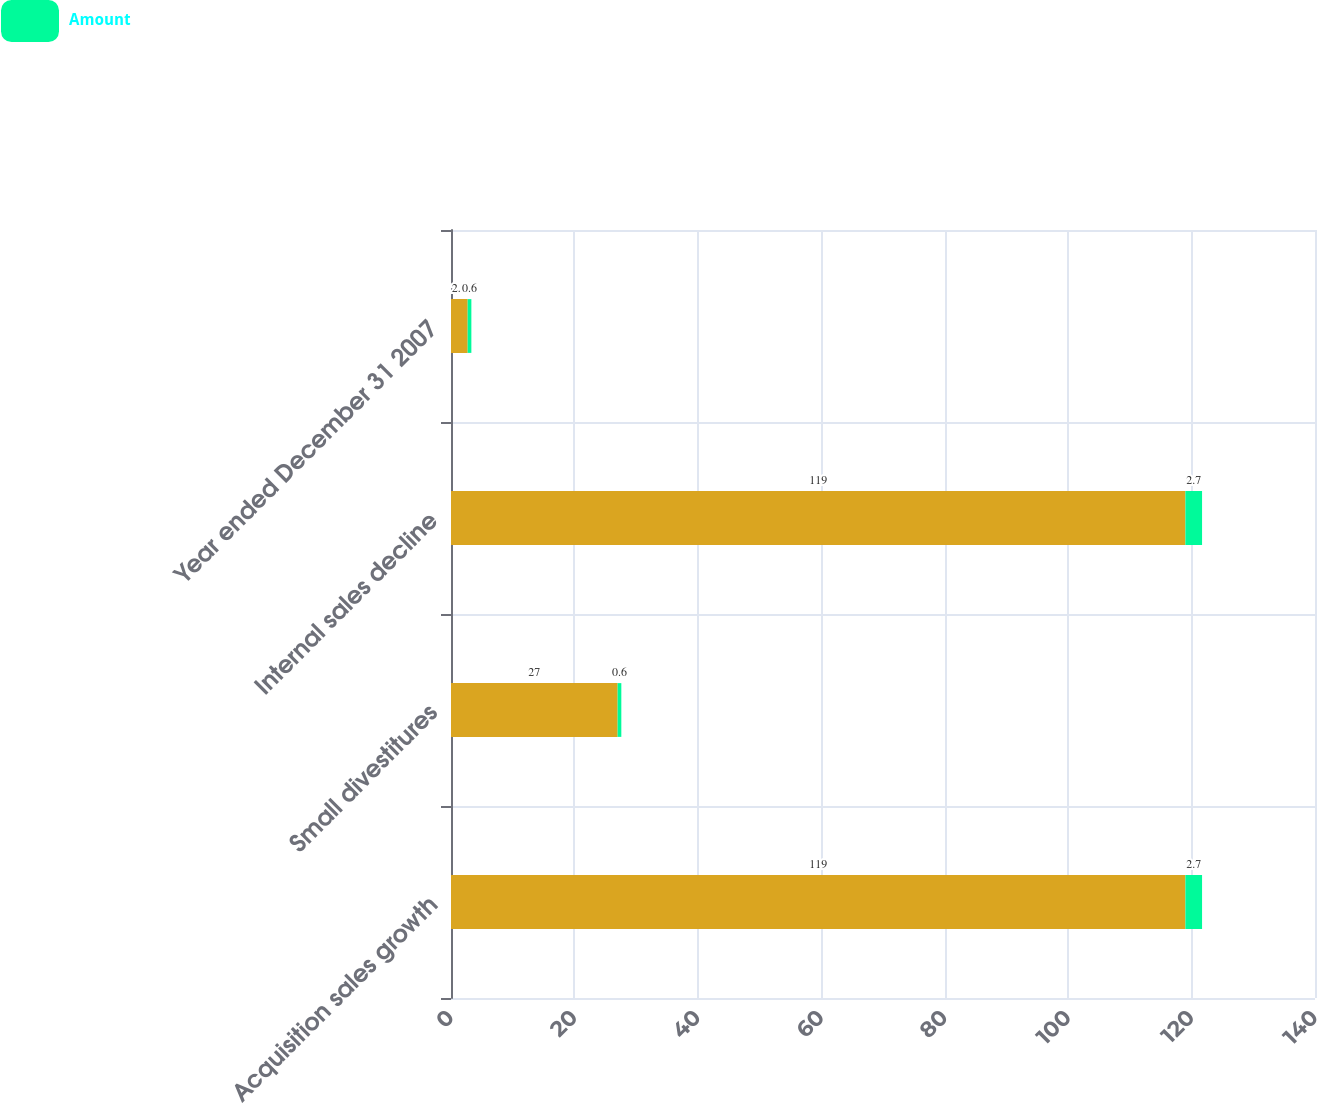<chart> <loc_0><loc_0><loc_500><loc_500><stacked_bar_chart><ecel><fcel>Acquisition sales growth<fcel>Small divestitures<fcel>Internal sales decline<fcel>Year ended December 31 2007<nl><fcel>nan<fcel>119<fcel>27<fcel>119<fcel>2.7<nl><fcel>Amount<fcel>2.7<fcel>0.6<fcel>2.7<fcel>0.6<nl></chart> 